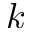<formula> <loc_0><loc_0><loc_500><loc_500>k</formula> 